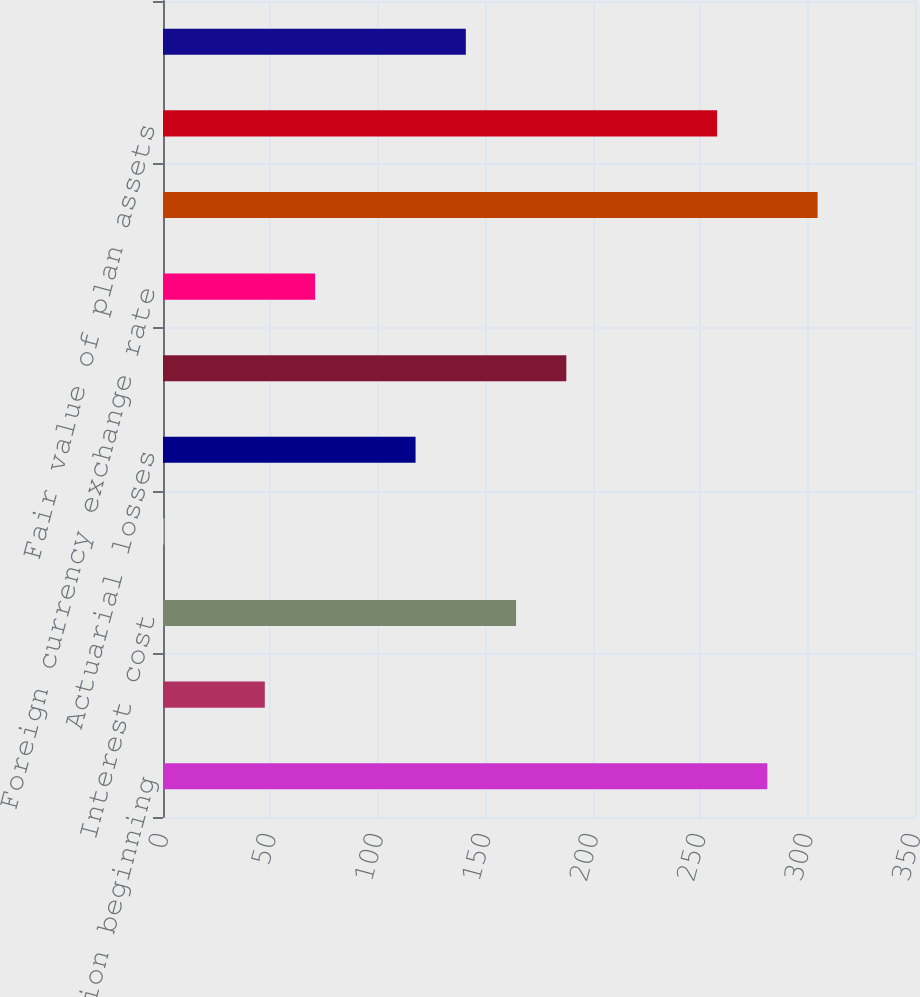Convert chart to OTSL. <chart><loc_0><loc_0><loc_500><loc_500><bar_chart><fcel>Benefit obligation beginning<fcel>Service cost<fcel>Interest cost<fcel>Plan participants'<fcel>Actuarial losses<fcel>Benefits paid<fcel>Foreign currency exchange rate<fcel>Benefit obligation end of<fcel>Fair value of plan assets<fcel>Actual return on plan assets<nl><fcel>281.28<fcel>47.38<fcel>164.33<fcel>0.6<fcel>117.55<fcel>187.72<fcel>70.77<fcel>304.67<fcel>257.89<fcel>140.94<nl></chart> 